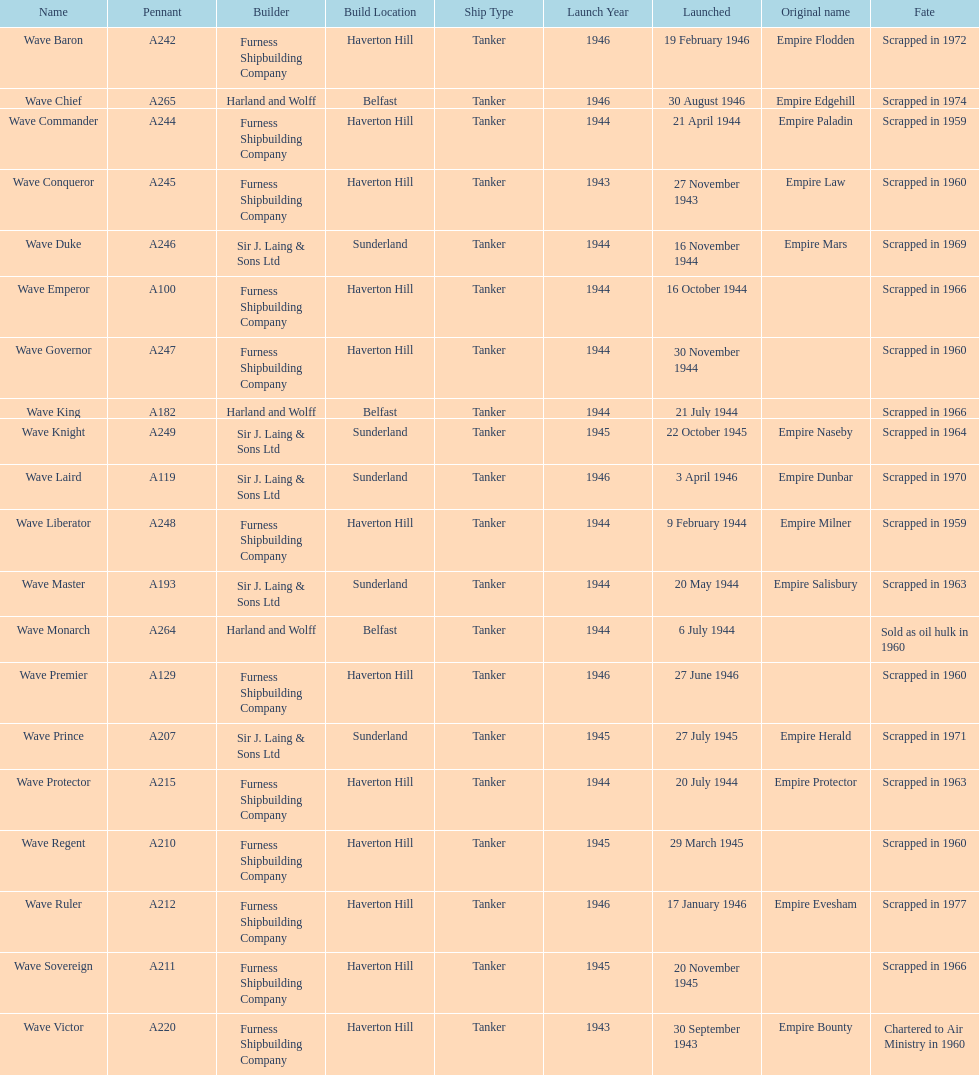What is the name of the last ship that was scrapped? Wave Ruler. 